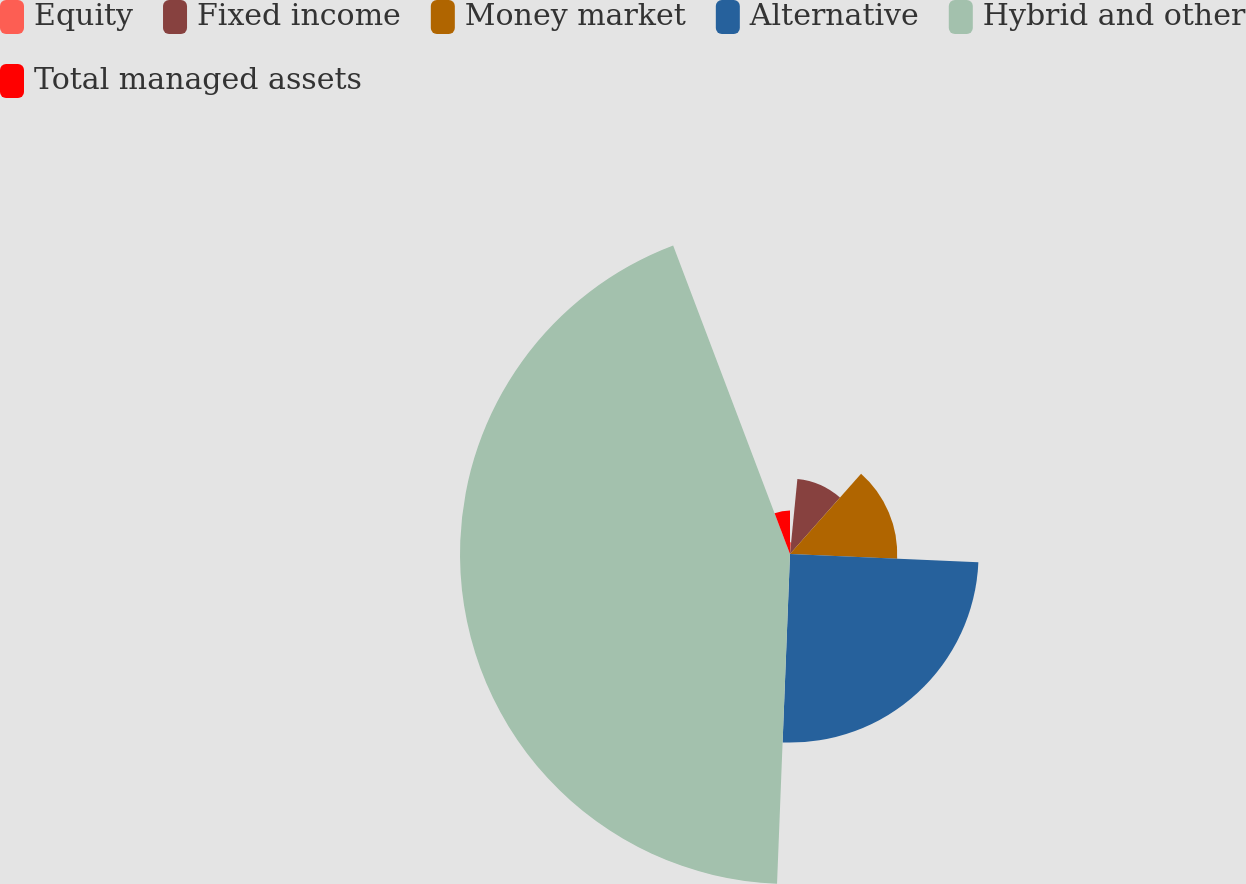<chart> <loc_0><loc_0><loc_500><loc_500><pie_chart><fcel>Equity<fcel>Fixed income<fcel>Money market<fcel>Alternative<fcel>Hybrid and other<fcel>Total managed assets<nl><fcel>1.56%<fcel>9.97%<fcel>14.17%<fcel>24.92%<fcel>43.61%<fcel>5.76%<nl></chart> 